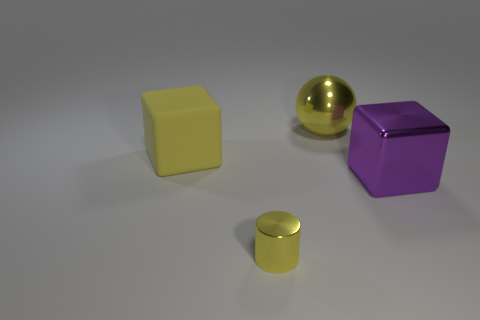The shiny thing in front of the purple object is what color?
Provide a short and direct response. Yellow. Are there fewer blocks that are to the left of the large rubber thing than large metal objects?
Give a very brief answer. Yes. Are the small yellow object and the yellow block made of the same material?
Provide a short and direct response. No. There is another matte thing that is the same shape as the big purple thing; what is its size?
Give a very brief answer. Large. How many things are either metal things right of the yellow sphere or yellow objects that are in front of the large purple metallic thing?
Keep it short and to the point. 2. Is the number of purple shiny blocks less than the number of small red blocks?
Keep it short and to the point. No. There is a cylinder; is its size the same as the block on the left side of the purple object?
Give a very brief answer. No. How many shiny things are either purple cubes or big yellow cubes?
Your answer should be compact. 1. Are there more yellow blocks than tiny blue rubber spheres?
Your response must be concise. Yes. What is the size of the metal thing that is the same color as the small cylinder?
Provide a succinct answer. Large. 